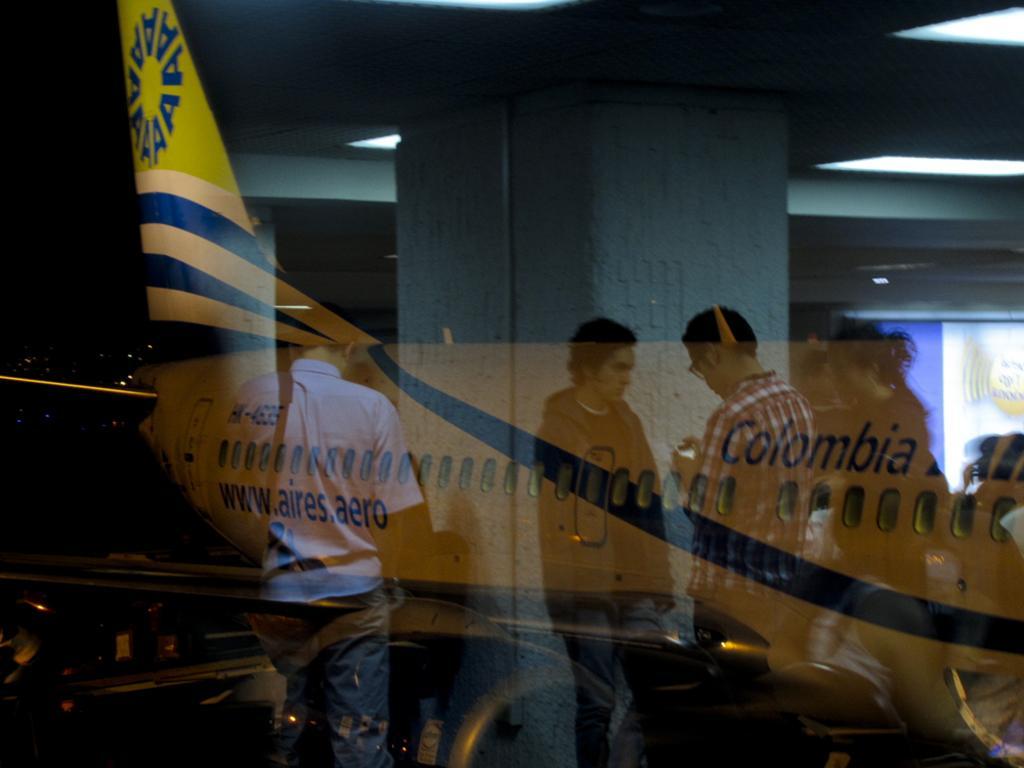How would you summarize this image in a sentence or two? In this image I can see reflection of an aeroplane on the glass. Also there is reflection of people and there is a pillar. 